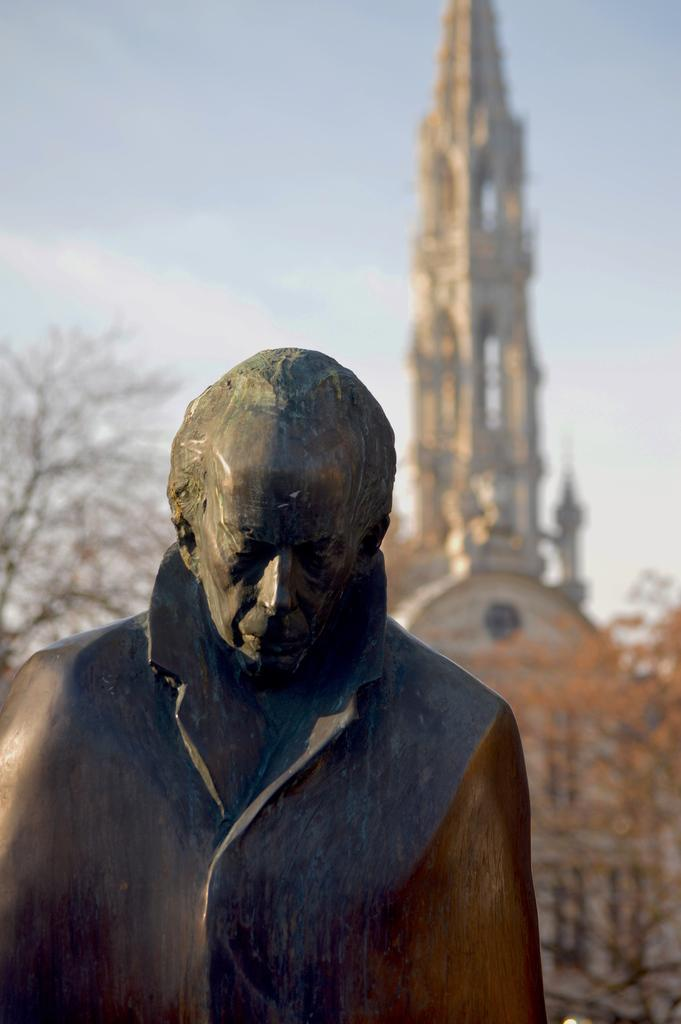What is the main subject in the image? There is a statue in the image. What can be seen behind the statue? There is a building behind the statue. What type of vegetation is present in the image? There are trees in the image. What is visible at the top of the image? The sky is visible at the top of the image. How many trucks are parked near the statue in the image? There are no trucks present in the image; it features a statue, a building, trees, and the sky. 